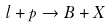Convert formula to latex. <formula><loc_0><loc_0><loc_500><loc_500>l + p \to B + X</formula> 